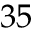<formula> <loc_0><loc_0><loc_500><loc_500>3 5</formula> 